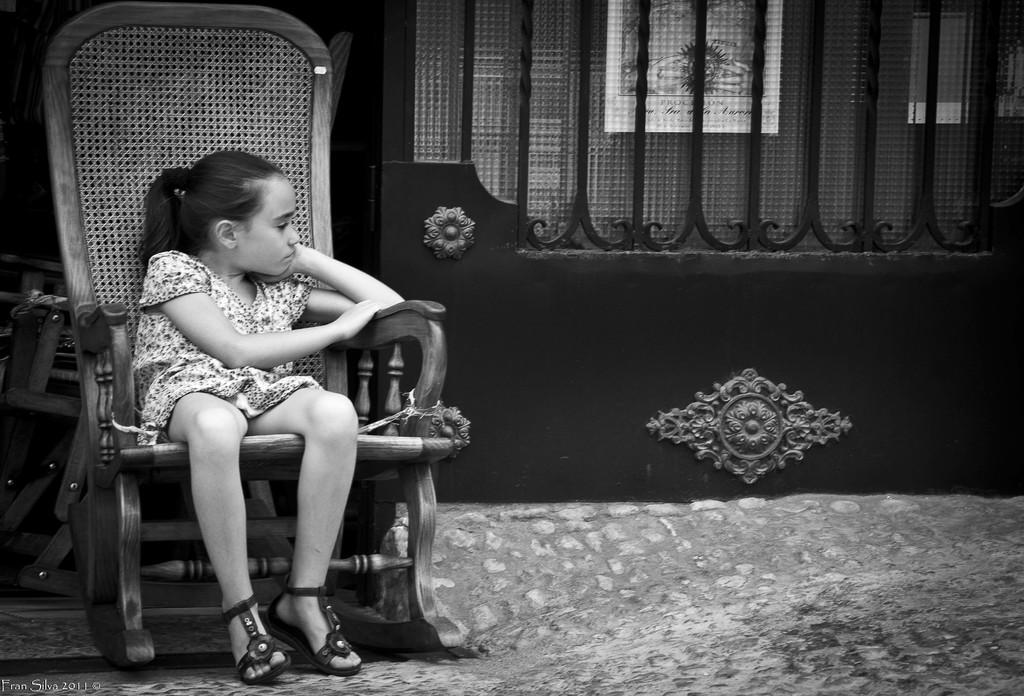What is the girl in the image doing? The girl is sitting in a chair. What can be seen in the background of the image? There is a fence in the image. Is there anything on the fence? Yes, there is a poster on the back side of the fence. What type of rice is being served to the visitor in the image? There is no rice or visitor present in the image. What is the girl doing with her mouth in the image? The image does not show the girl's mouth or any activity involving her mouth. 